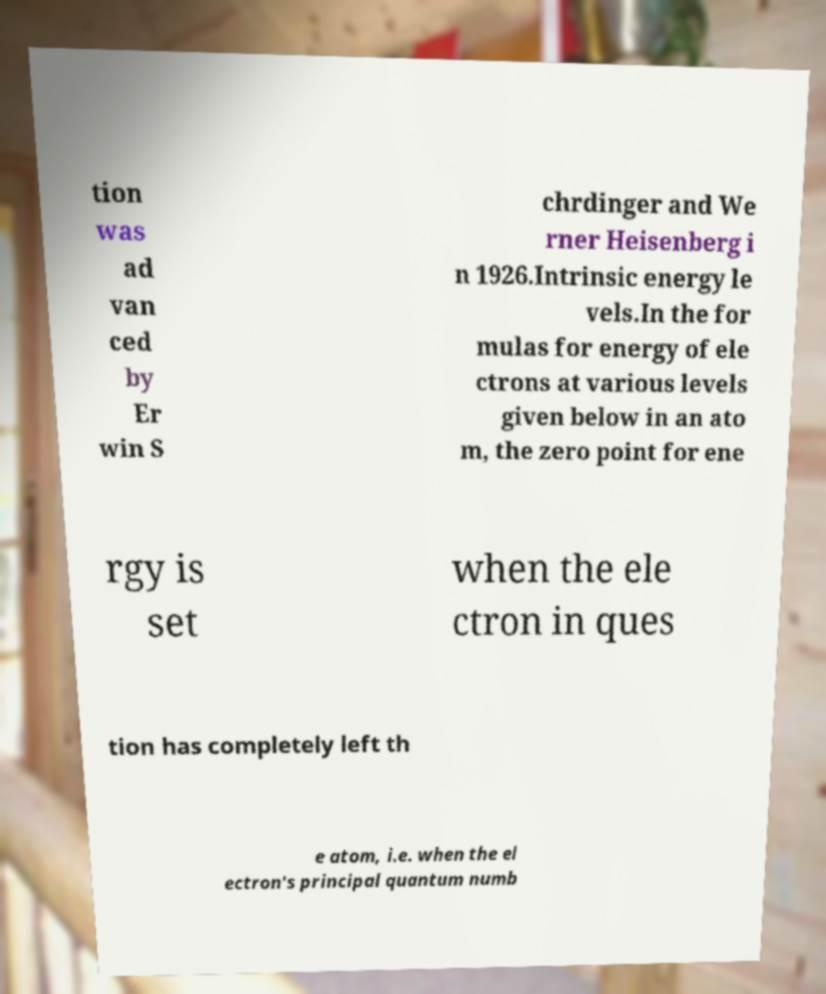Can you accurately transcribe the text from the provided image for me? tion was ad van ced by Er win S chrdinger and We rner Heisenberg i n 1926.Intrinsic energy le vels.In the for mulas for energy of ele ctrons at various levels given below in an ato m, the zero point for ene rgy is set when the ele ctron in ques tion has completely left th e atom, i.e. when the el ectron's principal quantum numb 